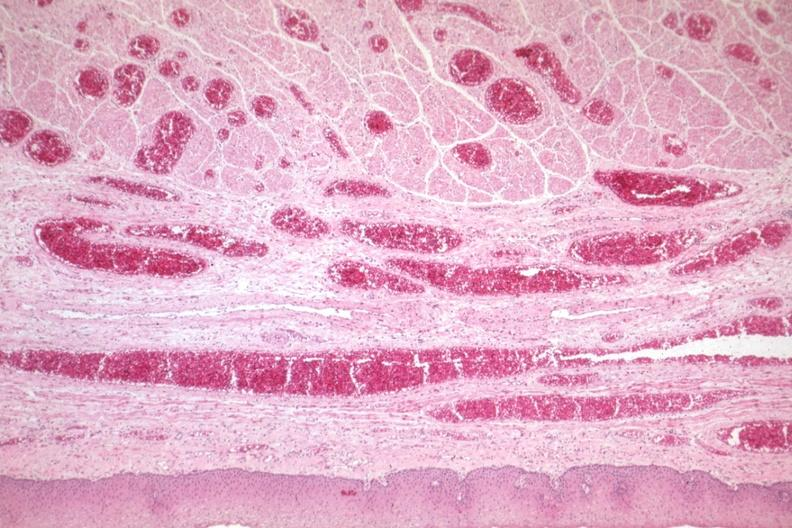s esophagus present?
Answer the question using a single word or phrase. Yes 